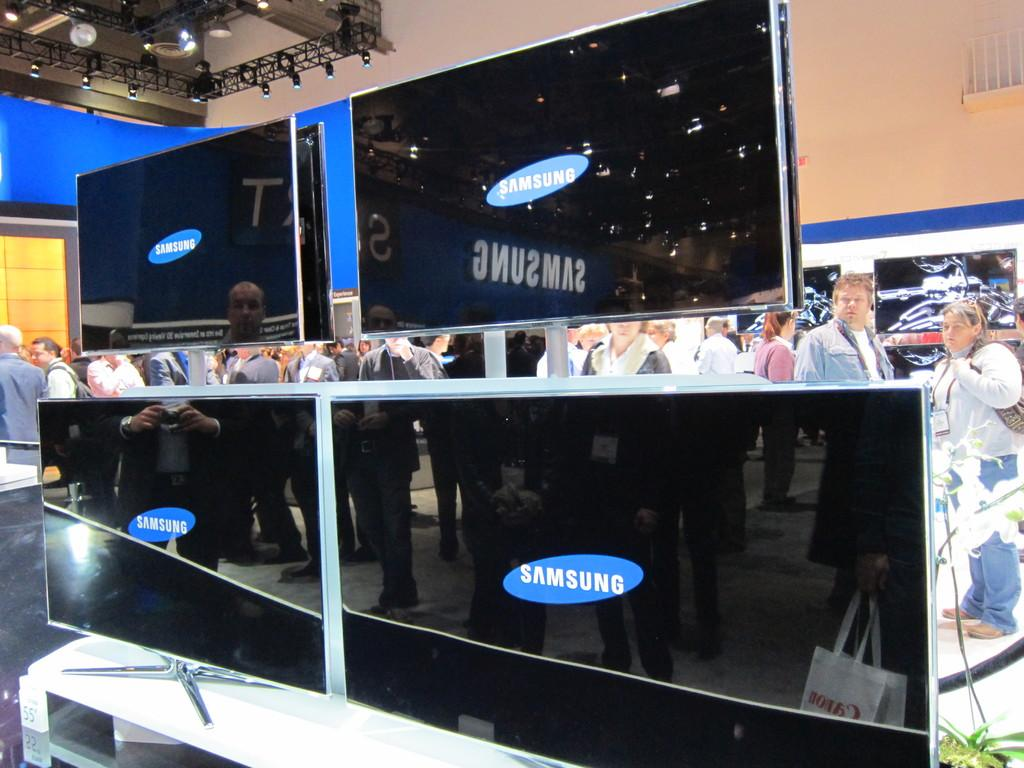<image>
Provide a brief description of the given image. Several black Samsung brand televisions are on display. 